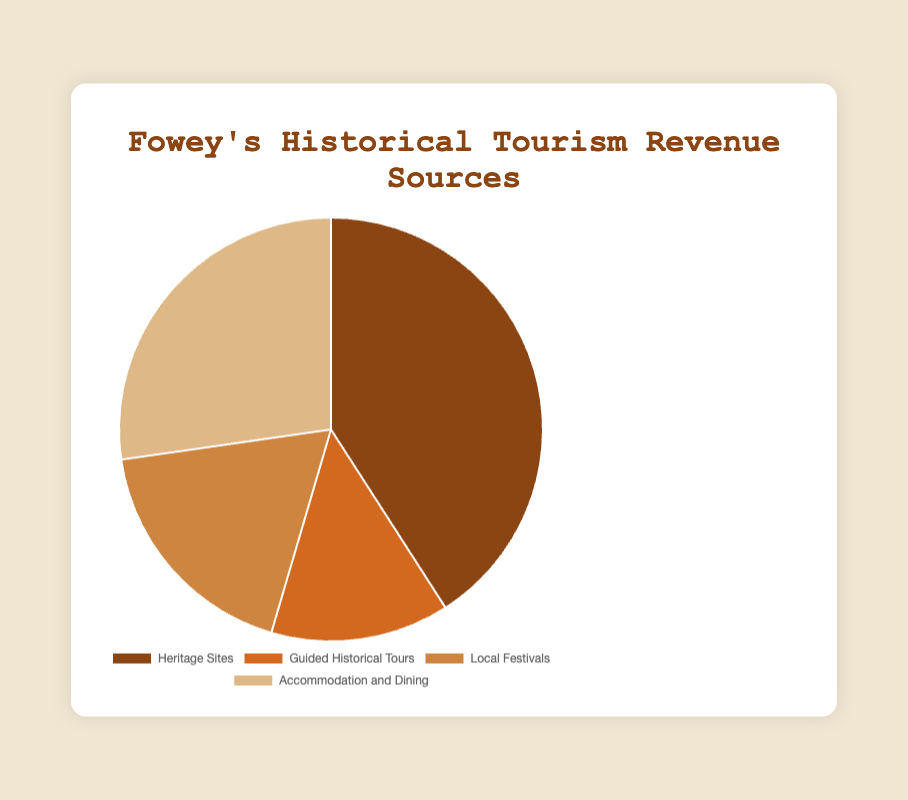What's the largest source of historical tourism revenue in Fowey? The largest slice of the pie chart represents the greatest revenue source. Based on the chart, Heritage Sites (St. Catherine's Castle, Fowey Museum) has the largest value at £450,000.
Answer: Heritage Sites (St. Catherine's Castle, Fowey Museum) What's the combined revenue from Local Festivals and Guided Historical Tours? To find the combined revenue, add the revenue from Local Festivals (£200,000) and Guided Historical Tours (£150,000). £200,000 + £150,000 = £350,000.
Answer: £350,000 Which source contributes more to the revenue: Accommodation and Dining or Guided Historical Tours? By comparing the two data points, Accommodation and Dining has a revenue of £300,000 while Guided Historical Tours has £150,000. £300,000 is greater than £150,000.
Answer: Accommodation and Dining What's the percentage of the total revenue contributed by Heritage Sites? First, sum up all the revenues: £450,000 (Heritage Sites) + £150,000 (Guided Historical Tours) + £200,000 (Local Festivals) + £300,000 (Accommodation and Dining) = £1,100,000. Then, calculate the percentage: (£450,000 / £1,100,000) * 100% ≈ 40.9%.
Answer: ≈ 40.9% How much more revenue does Accommodation and Dining generate compared to Local Festivals? Subtract the revenue from Local Festivals (£200,000) from Accommodation and Dining (£300,000). £300,000 - £200,000 = £100,000.
Answer: £100,000 What is the smallest source of historical tourism revenue in Fowey, and how much does it generate? The smallest slice of the pie chart corresponds to the lowest revenue source. Guided Historical Tours generate the lowest revenue, which is £150,000.
Answer: Guided Historical Tours, £150,000 What is the average revenue per source? To find the average, sum up all revenues: £450,000 (Heritage Sites) + £150,000 (Guided Historical Tours) + £200,000 (Local Festivals) + £300,000 (Accommodation and Dining) = £1,100,000. Then, divide by the number of sources (4). £1,100,000 / 4 = £275,000.
Answer: £275,000 Which two sources combined contribute to more than half of the total revenue? To determine this, find the combinations that add up to more than 50% of the total revenue (£1,100,000). The combined revenue from Heritage Sites (£450,000) and Accommodation and Dining (£300,000) is £750,000, which is more than 50% of £1,100,000.
Answer: Heritage Sites and Accommodation and Dining 